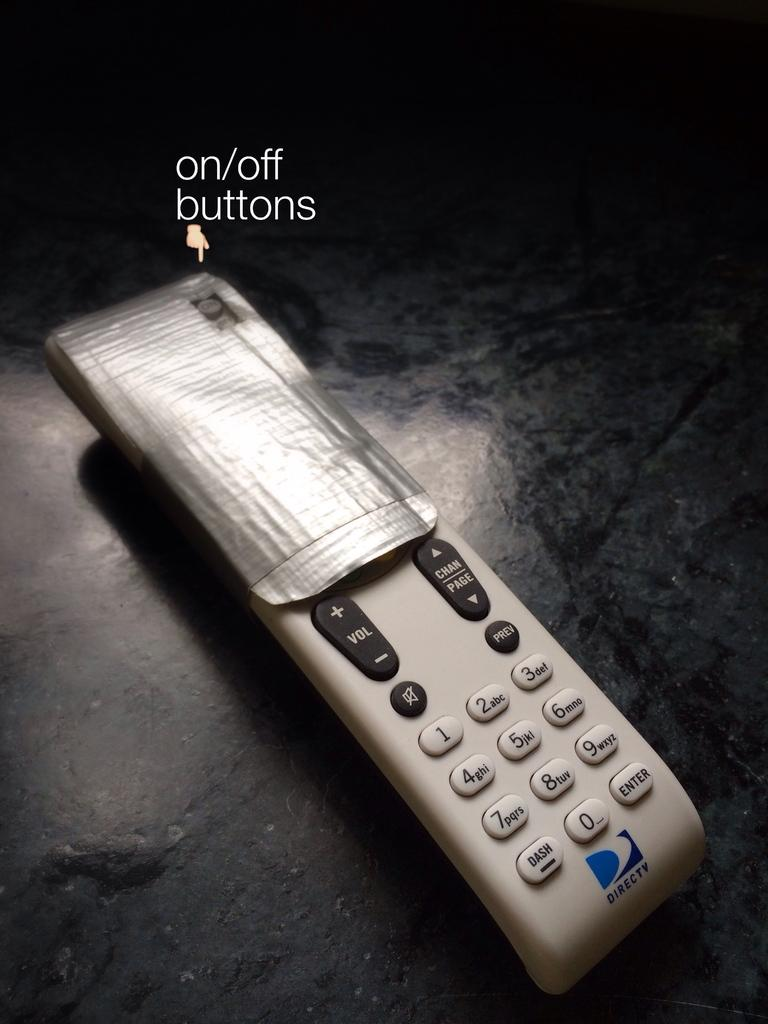<image>
Render a clear and concise summary of the photo. White remote controller for Directv with the top taped. 